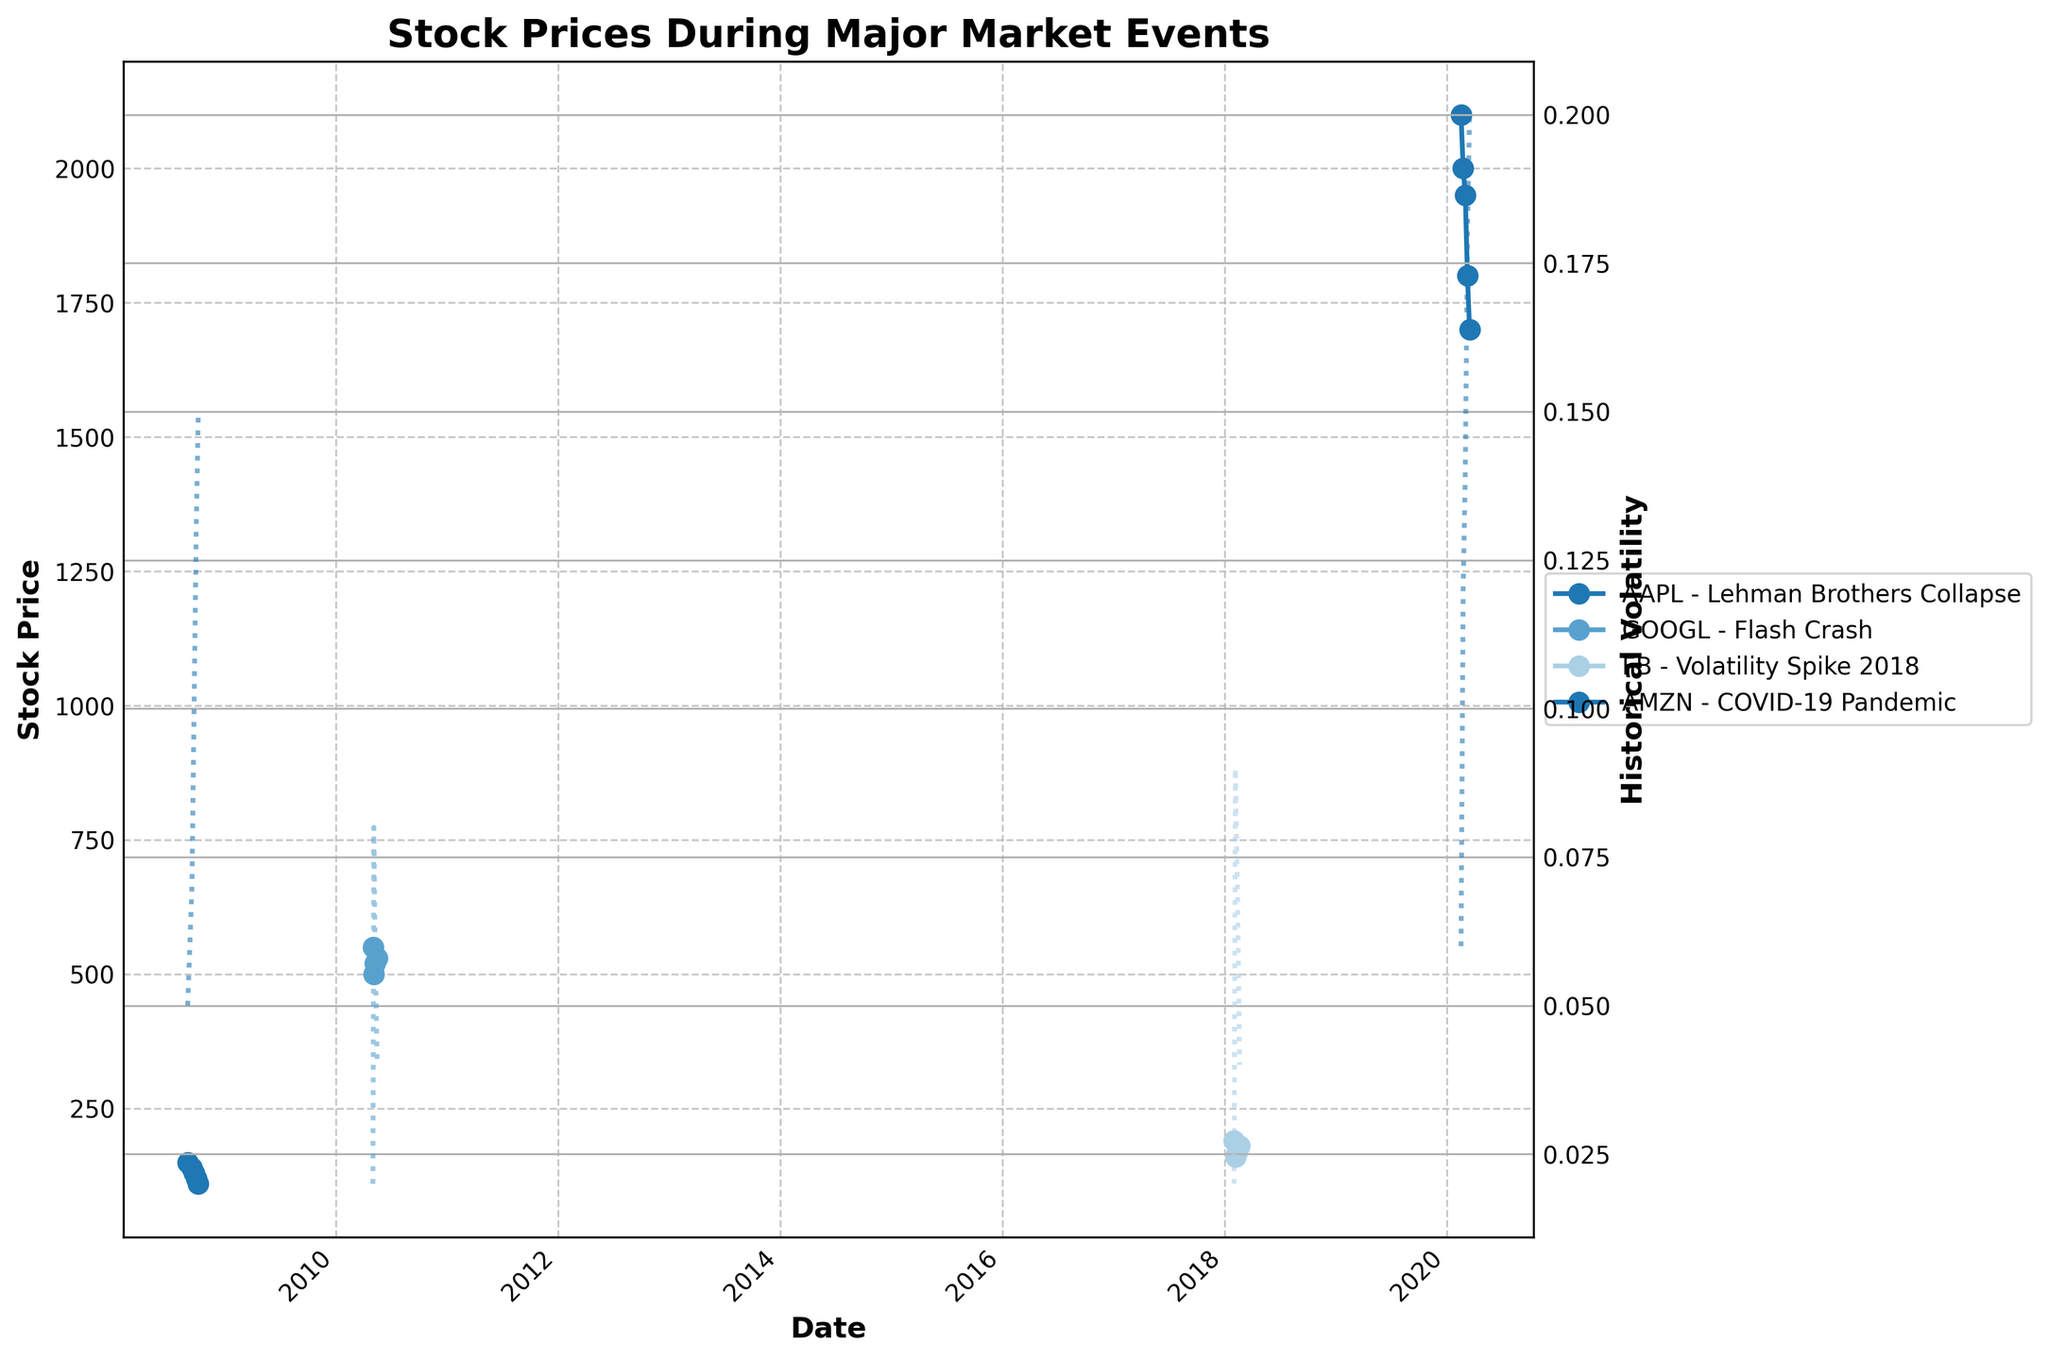what is the title of the plot? The title of the plot is located at the top of the figure and provides a summary of what the plot is about.
Answer: Stock Prices During Major Market Events which stock had the highest historical volatility during its respective market event? By looking at the secondary y-axis (Historical Volatility) and the lines corresponding to each stock, we observe that AMZN during the COVID-19 Pandemic had the highest volatility peaking at 0.20.
Answer: AMZN how did AAPL's stock price change during the Lehman Brothers Collapse? Start by looking at the dates and prices for AAPL during the specified event. The price started at 150, then dropped progressively to 140, 130, 120, and finally 110.
Answer: It decreased from 150 to 110 on the day of the Flash Crash, what was the price drop in GOOGL? Examining the specific date 2010-05-06 for GOOGL, compare the prices just before and on the day. The price dropped from 550 to 500.
Answer: 50 points which event had the most significant increase in historical volatility for FB? By examining the historical volatility lines for FB during the Volatility Spike 2018 event, and comparing the values before and during the spikes, we see that on 2018-02-05, the volatility peaked at 0.09 from 0.02 on 2018-02-01.
Answer: Volatility Spike 2018 what is the relationship between the increase in historical volatility and the stock price for AMZN during the COVID-19 Pandemic? As the historical volatility for AMZN increases during the COVID-19 Pandemic, the stock price decreases. This shows an inverse relationship where higher volatility coincides with a falling stock price.
Answer: Inverse relationship which stock experienced the least historical volatility change during its respective event? By examining the historical volatility lines for each event and stock, it's apparent that GOOGL during the Flash Crash had the least pronounced fluctuations.
Answer: GOOGL compare the final stock prices at the end of each event for AAPL and AMZN. Which was higher? Looking at the last data points for each stock during their respective events, AAPL ended at 110 (2008-10-06) and AMZN ended at 1700 (2020-03-16).
Answer: AMZN which stock had a price recovery after an initial drop during its event? By examining the plotted lines for stock prices, GOOGL shows a recovery after dropping initially on 2010-05-06 and gradually rising again.
Answer: GOOGL what pattern can you observe in FB's historical volatility during the Volatility Spike 2018 event? By looking at the historical volatility line for FB, you can observe that the volatility initially spikes significantly on 2018-02-05 and then gradually decreases over the subsequent dates.
Answer: Spikes first, then decreases 